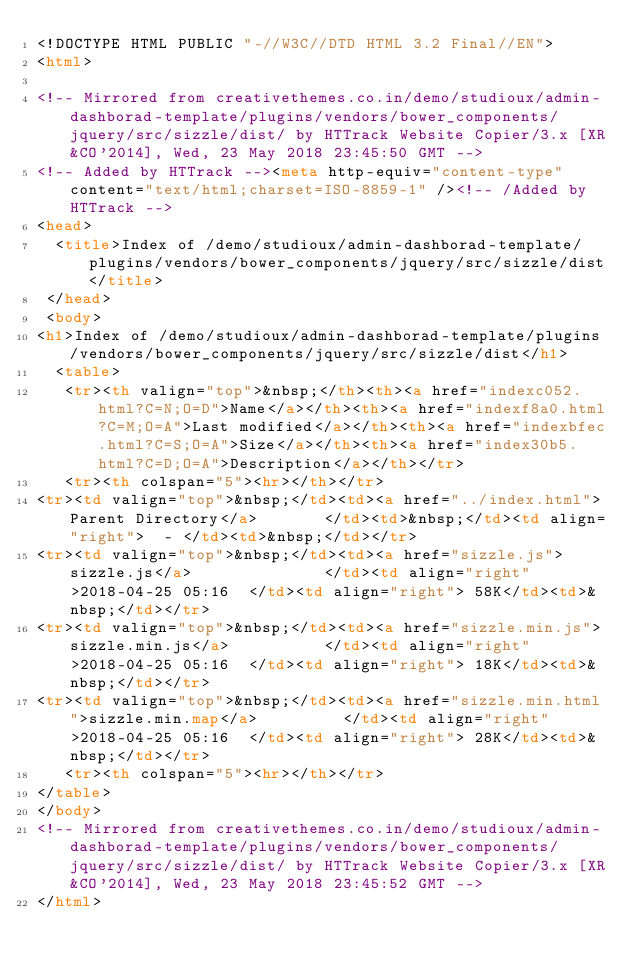Convert code to text. <code><loc_0><loc_0><loc_500><loc_500><_HTML_><!DOCTYPE HTML PUBLIC "-//W3C//DTD HTML 3.2 Final//EN">
<html>
 
<!-- Mirrored from creativethemes.co.in/demo/studioux/admin-dashborad-template/plugins/vendors/bower_components/jquery/src/sizzle/dist/ by HTTrack Website Copier/3.x [XR&CO'2014], Wed, 23 May 2018 23:45:50 GMT -->
<!-- Added by HTTrack --><meta http-equiv="content-type" content="text/html;charset=ISO-8859-1" /><!-- /Added by HTTrack -->
<head>
  <title>Index of /demo/studioux/admin-dashborad-template/plugins/vendors/bower_components/jquery/src/sizzle/dist</title>
 </head>
 <body>
<h1>Index of /demo/studioux/admin-dashborad-template/plugins/vendors/bower_components/jquery/src/sizzle/dist</h1>
  <table>
   <tr><th valign="top">&nbsp;</th><th><a href="indexc052.html?C=N;O=D">Name</a></th><th><a href="indexf8a0.html?C=M;O=A">Last modified</a></th><th><a href="indexbfec.html?C=S;O=A">Size</a></th><th><a href="index30b5.html?C=D;O=A">Description</a></th></tr>
   <tr><th colspan="5"><hr></th></tr>
<tr><td valign="top">&nbsp;</td><td><a href="../index.html">Parent Directory</a>       </td><td>&nbsp;</td><td align="right">  - </td><td>&nbsp;</td></tr>
<tr><td valign="top">&nbsp;</td><td><a href="sizzle.js">sizzle.js</a>              </td><td align="right">2018-04-25 05:16  </td><td align="right"> 58K</td><td>&nbsp;</td></tr>
<tr><td valign="top">&nbsp;</td><td><a href="sizzle.min.js">sizzle.min.js</a>          </td><td align="right">2018-04-25 05:16  </td><td align="right"> 18K</td><td>&nbsp;</td></tr>
<tr><td valign="top">&nbsp;</td><td><a href="sizzle.min.html">sizzle.min.map</a>         </td><td align="right">2018-04-25 05:16  </td><td align="right"> 28K</td><td>&nbsp;</td></tr>
   <tr><th colspan="5"><hr></th></tr>
</table>
</body>
<!-- Mirrored from creativethemes.co.in/demo/studioux/admin-dashborad-template/plugins/vendors/bower_components/jquery/src/sizzle/dist/ by HTTrack Website Copier/3.x [XR&CO'2014], Wed, 23 May 2018 23:45:52 GMT -->
</html>
</code> 